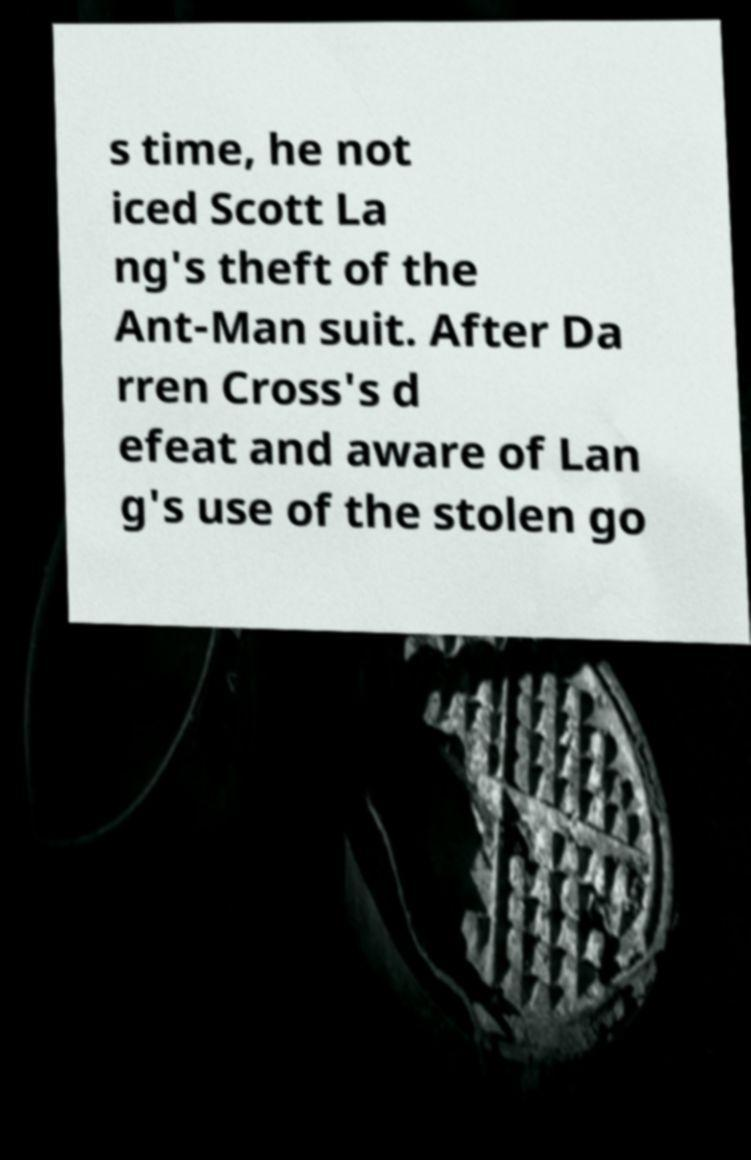I need the written content from this picture converted into text. Can you do that? s time, he not iced Scott La ng's theft of the Ant-Man suit. After Da rren Cross's d efeat and aware of Lan g's use of the stolen go 